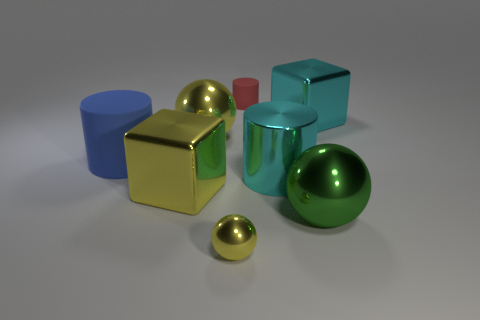The blue rubber cylinder has what size?
Keep it short and to the point. Large. Does the cyan cylinder have the same size as the cylinder that is behind the blue cylinder?
Keep it short and to the point. No. What color is the small thing that is behind the cube behind the blue matte cylinder?
Your answer should be compact. Red. Are there an equal number of blue matte cylinders that are in front of the tiny yellow metal ball and large yellow metal spheres in front of the big yellow sphere?
Offer a very short reply. Yes. Is the large block in front of the large cyan metallic block made of the same material as the small yellow ball?
Make the answer very short. Yes. The thing that is left of the green thing and behind the large yellow metallic ball is what color?
Offer a very short reply. Red. What number of red rubber objects are in front of the sphere that is behind the yellow cube?
Keep it short and to the point. 0. There is a cyan thing that is the same shape as the big blue thing; what is its material?
Provide a succinct answer. Metal. The big metal cylinder is what color?
Ensure brevity in your answer.  Cyan. How many things are either large matte cylinders or big yellow metallic cubes?
Your answer should be very brief. 2. 